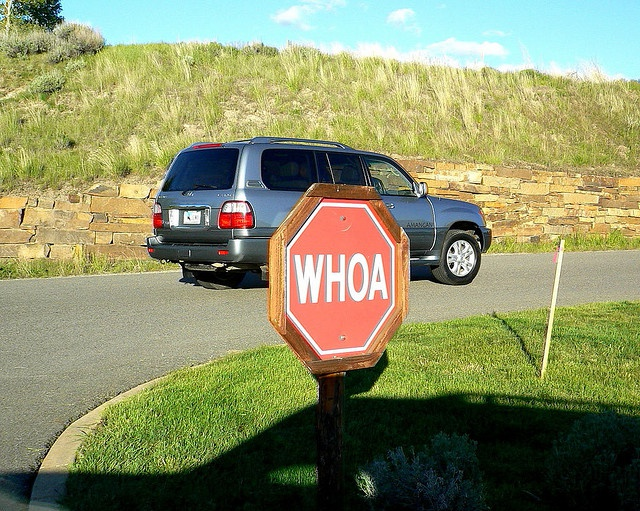Describe the objects in this image and their specific colors. I can see car in lightblue, black, and gray tones and stop sign in lightblue, salmon, white, and lightpink tones in this image. 